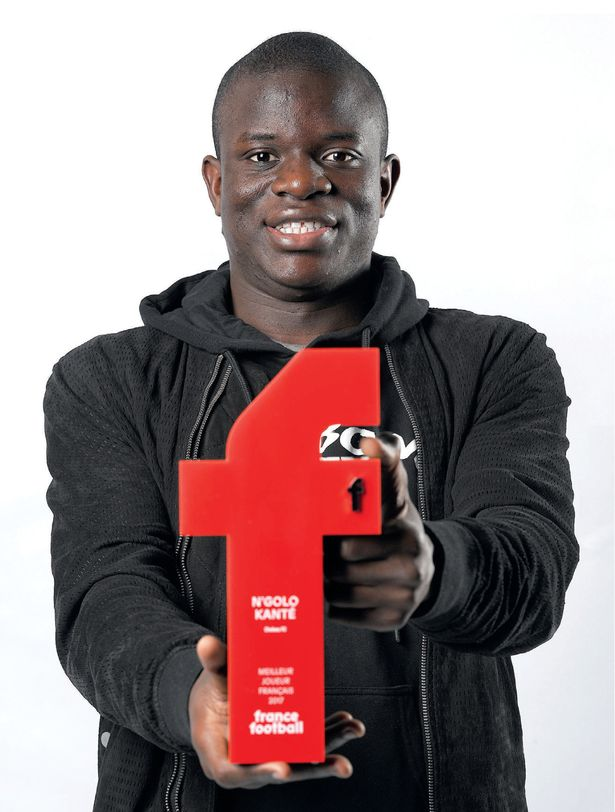What might have contributed to this individual's recognition as the 'Player of the Year'? This individual was likely recognized as the 'Player of the Year' due to several factors. He may have demonstrated consistent high-level performance, including critical contributions to his team's success, outstanding skill in both offensive and defensive plays, and strong leadership on and off the field. Additionally, his sportsmanship, commitment to the game, and possibly significant moments in important matches could have played a role in achieving this honor. 